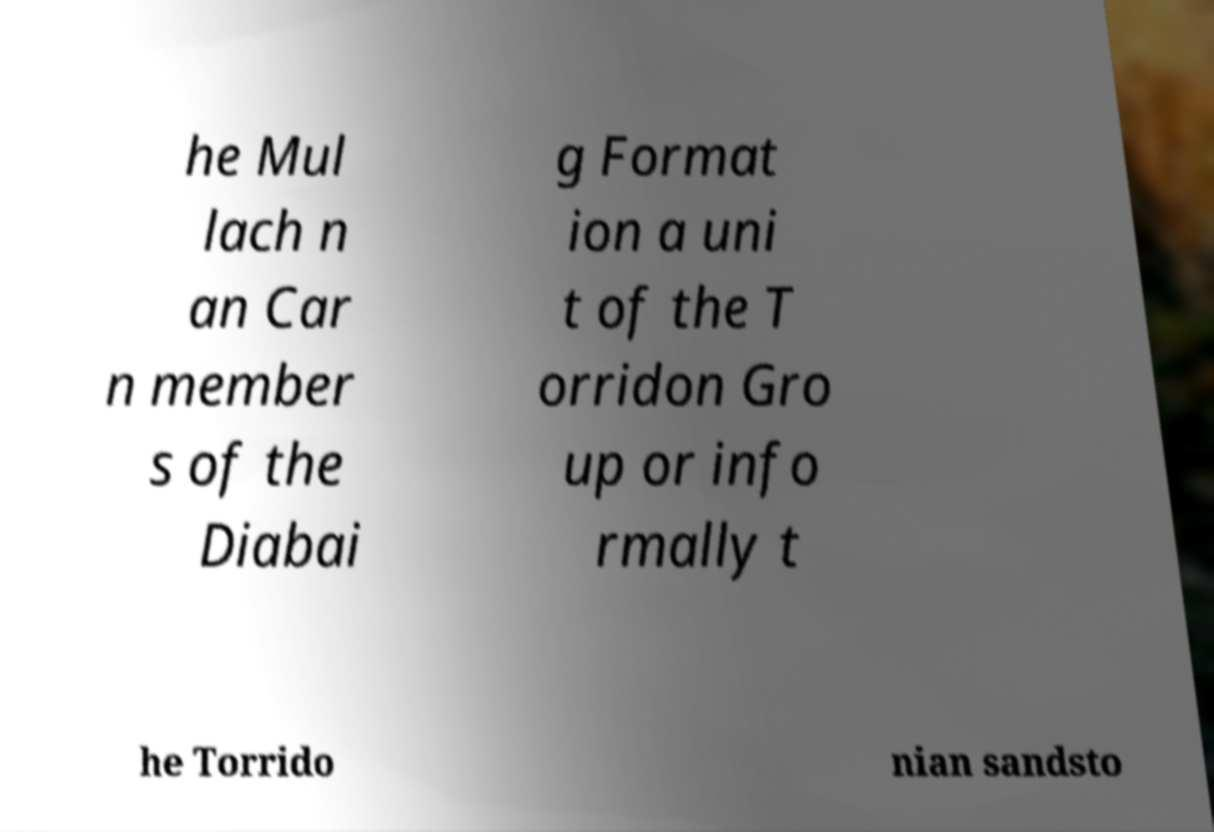Could you extract and type out the text from this image? he Mul lach n an Car n member s of the Diabai g Format ion a uni t of the T orridon Gro up or info rmally t he Torrido nian sandsto 